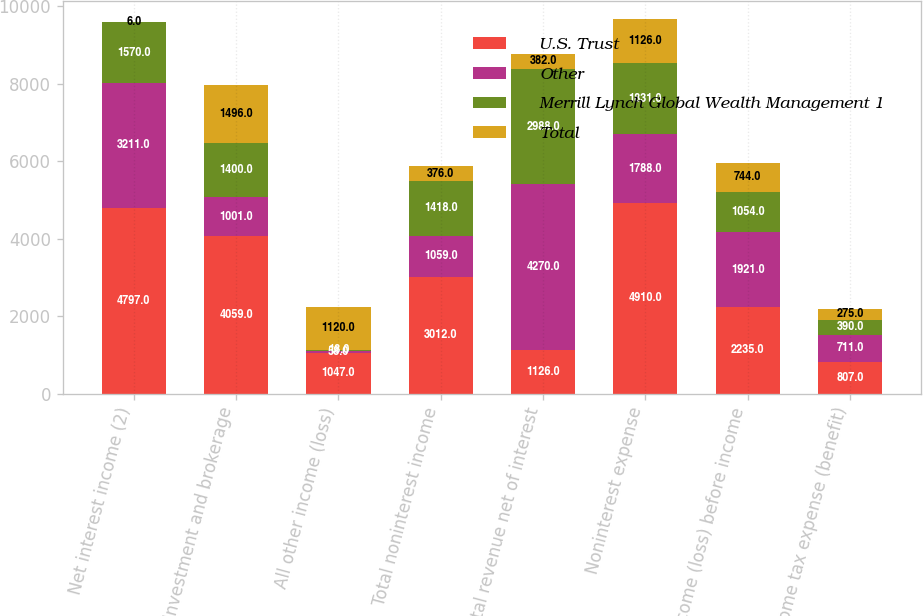Convert chart to OTSL. <chart><loc_0><loc_0><loc_500><loc_500><stacked_bar_chart><ecel><fcel>Net interest income (2)<fcel>Investment and brokerage<fcel>All other income (loss)<fcel>Total noninterest income<fcel>Total revenue net of interest<fcel>Noninterest expense<fcel>Income (loss) before income<fcel>Income tax expense (benefit)<nl><fcel>U.S. Trust<fcel>4797<fcel>4059<fcel>1047<fcel>3012<fcel>1126<fcel>4910<fcel>2235<fcel>807<nl><fcel>Other<fcel>3211<fcel>1001<fcel>58<fcel>1059<fcel>4270<fcel>1788<fcel>1921<fcel>711<nl><fcel>Merrill Lynch Global Wealth Management 1<fcel>1570<fcel>1400<fcel>18<fcel>1418<fcel>2988<fcel>1831<fcel>1054<fcel>390<nl><fcel>Total<fcel>6<fcel>1496<fcel>1120<fcel>376<fcel>382<fcel>1126<fcel>744<fcel>275<nl></chart> 